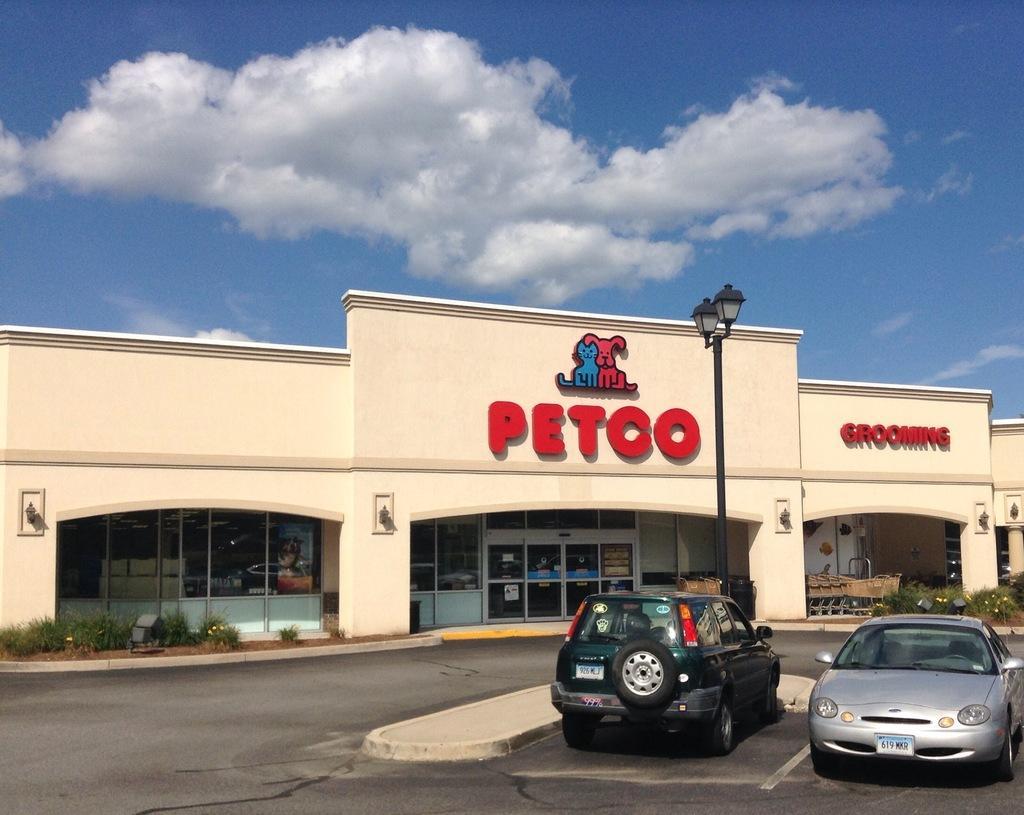Could you give a brief overview of what you see in this image? This picture is clicked outside. In the foreground we can see the cars parked on the road. In the center we can see the lamps attached to the pole and there is a building and we can see a picture of animals and the text on the building. On the left we can see the small portion of green grass. In the background there is a sky with the clouds. 